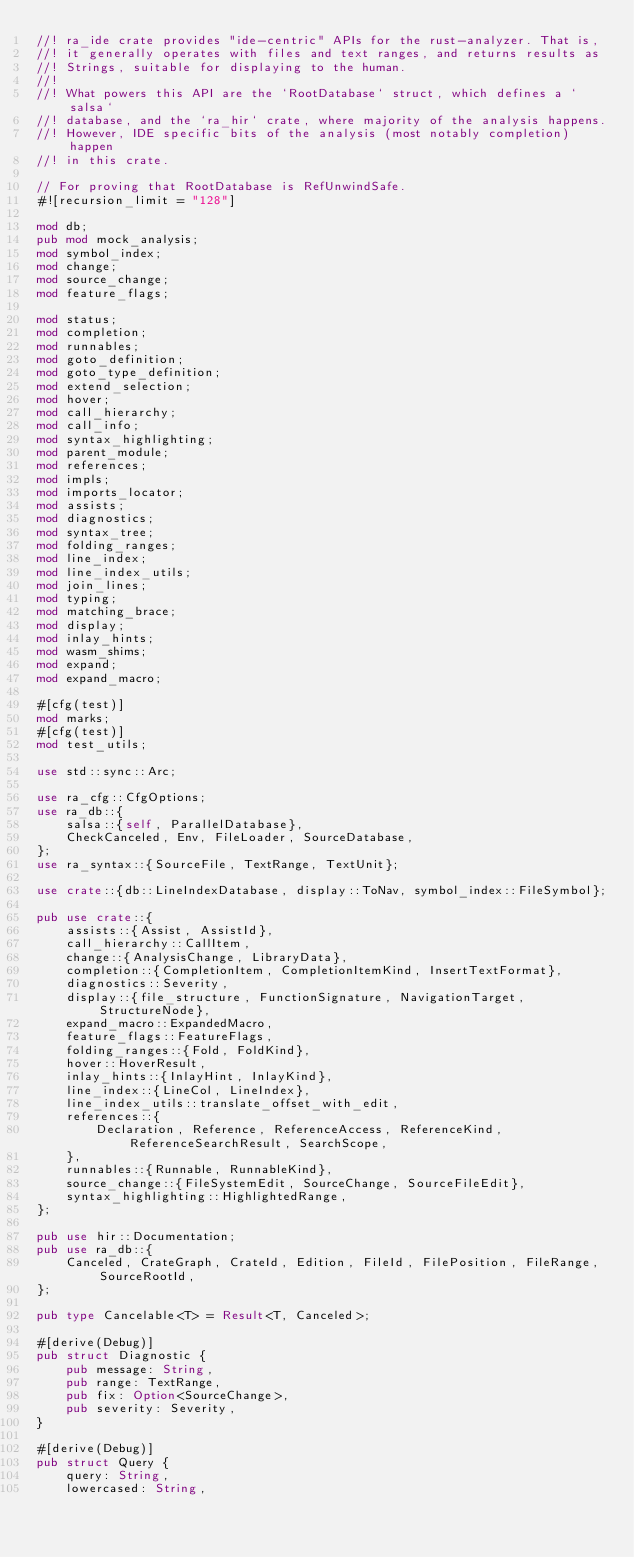Convert code to text. <code><loc_0><loc_0><loc_500><loc_500><_Rust_>//! ra_ide crate provides "ide-centric" APIs for the rust-analyzer. That is,
//! it generally operates with files and text ranges, and returns results as
//! Strings, suitable for displaying to the human.
//!
//! What powers this API are the `RootDatabase` struct, which defines a `salsa`
//! database, and the `ra_hir` crate, where majority of the analysis happens.
//! However, IDE specific bits of the analysis (most notably completion) happen
//! in this crate.

// For proving that RootDatabase is RefUnwindSafe.
#![recursion_limit = "128"]

mod db;
pub mod mock_analysis;
mod symbol_index;
mod change;
mod source_change;
mod feature_flags;

mod status;
mod completion;
mod runnables;
mod goto_definition;
mod goto_type_definition;
mod extend_selection;
mod hover;
mod call_hierarchy;
mod call_info;
mod syntax_highlighting;
mod parent_module;
mod references;
mod impls;
mod imports_locator;
mod assists;
mod diagnostics;
mod syntax_tree;
mod folding_ranges;
mod line_index;
mod line_index_utils;
mod join_lines;
mod typing;
mod matching_brace;
mod display;
mod inlay_hints;
mod wasm_shims;
mod expand;
mod expand_macro;

#[cfg(test)]
mod marks;
#[cfg(test)]
mod test_utils;

use std::sync::Arc;

use ra_cfg::CfgOptions;
use ra_db::{
    salsa::{self, ParallelDatabase},
    CheckCanceled, Env, FileLoader, SourceDatabase,
};
use ra_syntax::{SourceFile, TextRange, TextUnit};

use crate::{db::LineIndexDatabase, display::ToNav, symbol_index::FileSymbol};

pub use crate::{
    assists::{Assist, AssistId},
    call_hierarchy::CallItem,
    change::{AnalysisChange, LibraryData},
    completion::{CompletionItem, CompletionItemKind, InsertTextFormat},
    diagnostics::Severity,
    display::{file_structure, FunctionSignature, NavigationTarget, StructureNode},
    expand_macro::ExpandedMacro,
    feature_flags::FeatureFlags,
    folding_ranges::{Fold, FoldKind},
    hover::HoverResult,
    inlay_hints::{InlayHint, InlayKind},
    line_index::{LineCol, LineIndex},
    line_index_utils::translate_offset_with_edit,
    references::{
        Declaration, Reference, ReferenceAccess, ReferenceKind, ReferenceSearchResult, SearchScope,
    },
    runnables::{Runnable, RunnableKind},
    source_change::{FileSystemEdit, SourceChange, SourceFileEdit},
    syntax_highlighting::HighlightedRange,
};

pub use hir::Documentation;
pub use ra_db::{
    Canceled, CrateGraph, CrateId, Edition, FileId, FilePosition, FileRange, SourceRootId,
};

pub type Cancelable<T> = Result<T, Canceled>;

#[derive(Debug)]
pub struct Diagnostic {
    pub message: String,
    pub range: TextRange,
    pub fix: Option<SourceChange>,
    pub severity: Severity,
}

#[derive(Debug)]
pub struct Query {
    query: String,
    lowercased: String,</code> 